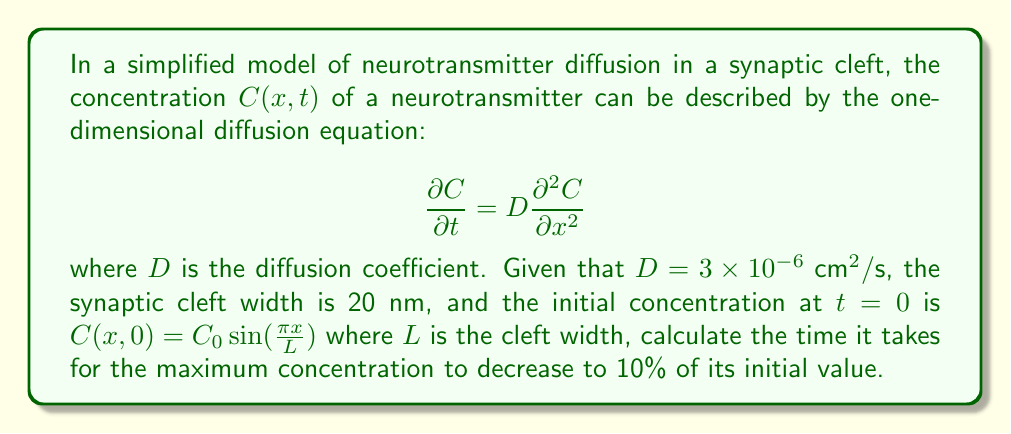Can you answer this question? To solve this problem, we'll follow these steps:

1) The general solution to the diffusion equation with the given initial condition is:

   $$C(x,t) = C_0\sin(\frac{\pi x}{L})e^{-\frac{D\pi^2t}{L^2}}$$

2) The maximum concentration occurs at $x = L/2$ at any time $t$:

   $$C_{max}(t) = C_0e^{-\frac{D\pi^2t}{L^2}}$$

3) We want to find $t$ when $C_{max}(t) = 0.1C_0$:

   $$0.1C_0 = C_0e^{-\frac{D\pi^2t}{L^2}}$$

4) Simplify:

   $$0.1 = e^{-\frac{D\pi^2t}{L^2}}$$

5) Take natural log of both sides:

   $$\ln(0.1) = -\frac{D\pi^2t}{L^2}$$

6) Solve for $t$:

   $$t = -\frac{L^2\ln(0.1)}{D\pi^2}$$

7) Now, let's substitute the values:
   $D = 3 \times 10^{-6} \text{ cm}^2/\text{s} = 3 \times 10^{-10} \text{ m}^2/\text{s}$
   $L = 20 \text{ nm} = 2 \times 10^{-8} \text{ m}$

   $$t = -\frac{(2 \times 10^{-8})^2 \ln(0.1)}{(3 \times 10^{-10})\pi^2}$$

8) Calculate:

   $$t \approx 1.5 \times 10^{-6} \text{ s} = 1.5 \text{ μs}$$
Answer: $1.5 \text{ μs}$ 